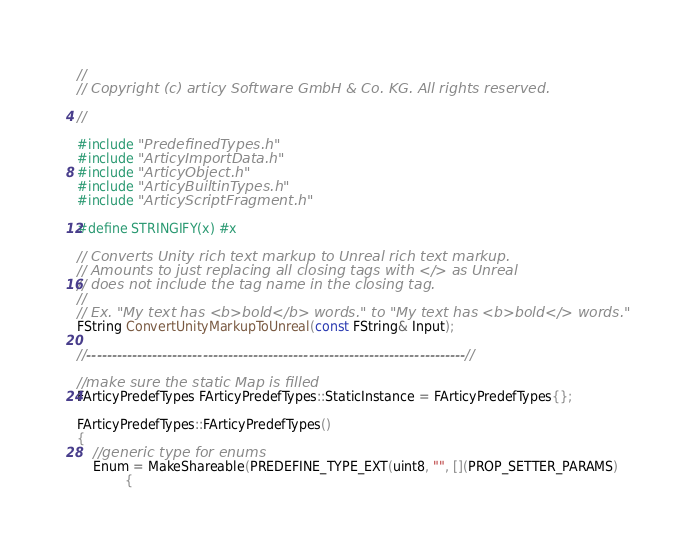<code> <loc_0><loc_0><loc_500><loc_500><_C++_>//  
// Copyright (c) articy Software GmbH & Co. KG. All rights reserved.  
 
//

#include "PredefinedTypes.h"
#include "ArticyImportData.h"
#include "ArticyObject.h"
#include "ArticyBuiltinTypes.h"
#include "ArticyScriptFragment.h"

#define STRINGIFY(x) #x

// Converts Unity rich text markup to Unreal rich text markup.
// Amounts to just replacing all closing tags with </> as Unreal
// does not include the tag name in the closing tag.
//
// Ex. "My text has <b>bold</b> words." to "My text has <b>bold</> words."
FString ConvertUnityMarkupToUnreal(const FString& Input);

//---------------------------------------------------------------------------//

//make sure the static Map is filled
FArticyPredefTypes FArticyPredefTypes::StaticInstance = FArticyPredefTypes{};

FArticyPredefTypes::FArticyPredefTypes()
{
	//generic type for enums
	Enum = MakeShareable(PREDEFINE_TYPE_EXT(uint8, "", [](PROP_SETTER_PARAMS)
			{</code> 